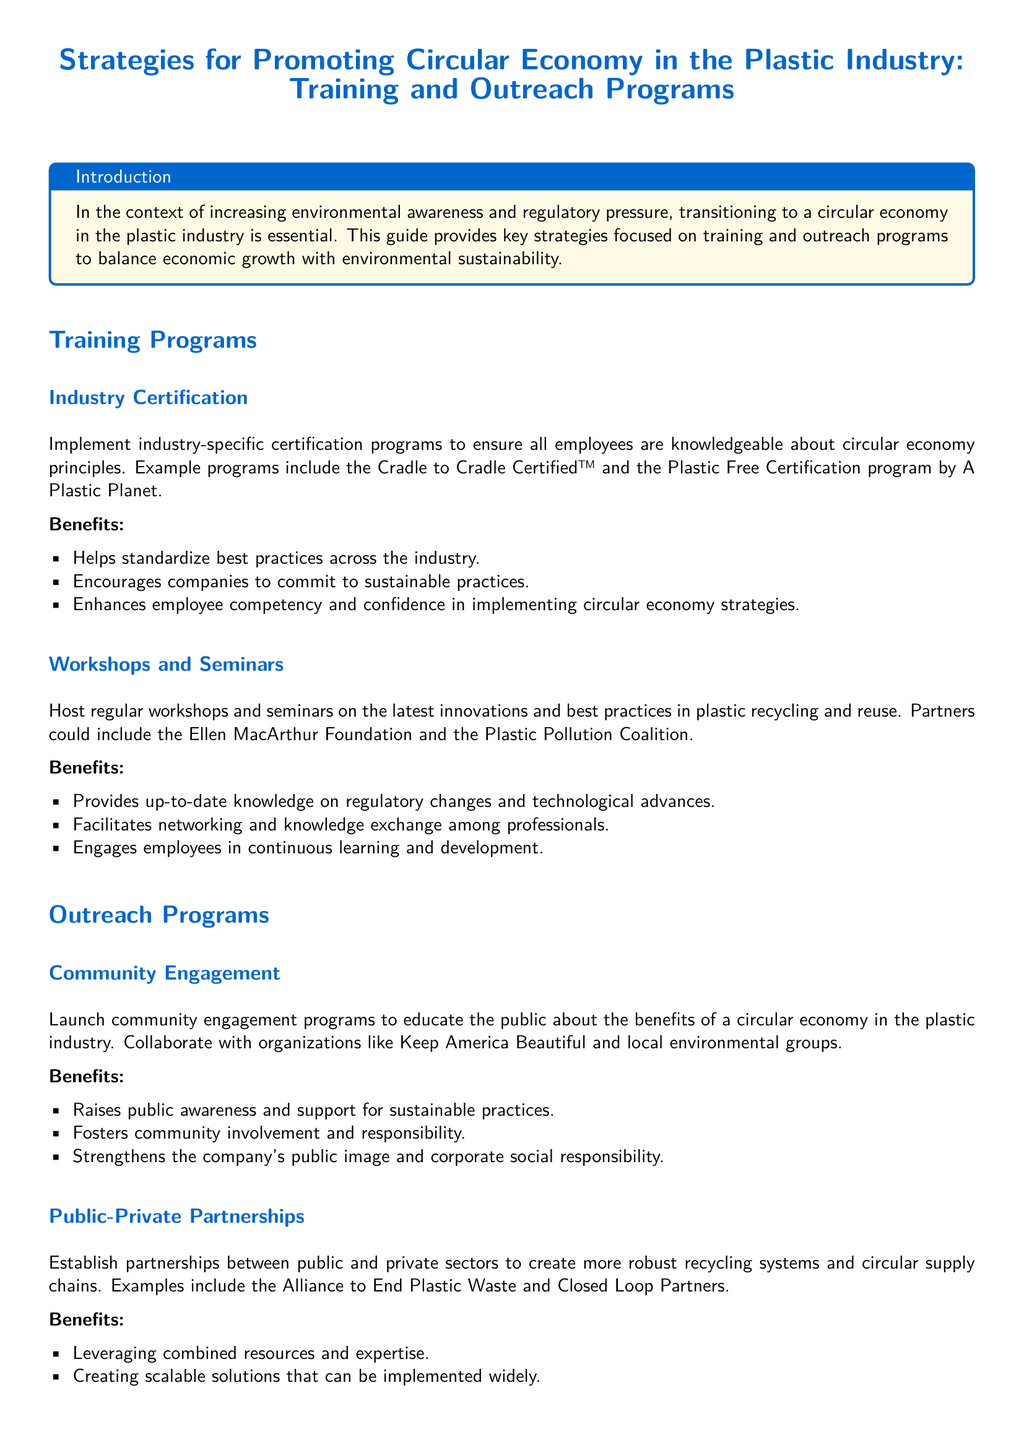what is the title of the document? The title is prominently displayed at the beginning of the document, summarizing its focus on strategies for the plastic industry.
Answer: Strategies for Promoting Circular Economy in the Plastic Industry: Training and Outreach Programs what is one example of an industry certification program mentioned? The document lists specific certification programs that employees can pursue for knowledge in circular economy principles.
Answer: Cradle to Cradle Certified™ who can be a partner for workshops and seminars? The document identifies organizations that could collaborate on educational events regarding plastic recycling and reuse.
Answer: Ellen MacArthur Foundation what is one benefit of community engagement programs? The benefits listed in the document provide insight into the impact of engaging communities in the circular economy.
Answer: Raises public awareness and support for sustainable practices name one public-private partnership mentioned. The document provides examples of collaborative initiatives between public and private sectors to enhance recycling systems.
Answer: Alliance to End Plastic Waste how do training programs help employees? The document discusses how training initiatives enhance employee skills in relation to circular economy practices.
Answer: Enhances employee competency and confidence what is a key outcome of establishing public-private partnerships? The document highlights the advantages of these partnerships in creating better recycling frameworks.
Answer: Leveraging combined resources and expertise what is the purpose of the introduction section in the document? The introduction provides a brief context and rationale for the strategies outlined in the user guide.
Answer: Transitioning to a circular economy in the plastic industry is essential which organization is mentioned as a collaborator for community engagement? The document specifies certain organizations that can partner by promoting circular economy public awareness.
Answer: Keep America Beautiful 